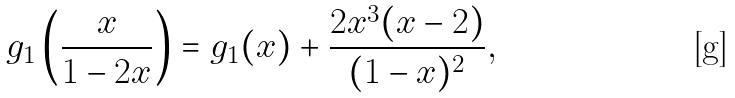Convert formula to latex. <formula><loc_0><loc_0><loc_500><loc_500>g _ { 1 } \left ( \frac { x } { 1 - 2 x } \right ) = g _ { 1 } ( x ) + \frac { 2 x ^ { 3 } ( x - 2 ) } { ( 1 - x ) ^ { 2 } } ,</formula> 